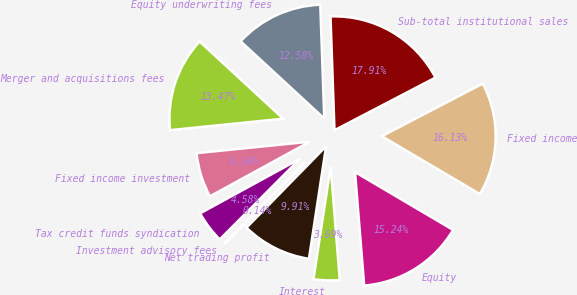<chart> <loc_0><loc_0><loc_500><loc_500><pie_chart><fcel>Equity<fcel>Fixed income<fcel>Sub-total institutional sales<fcel>Equity underwriting fees<fcel>Merger and acquisitions fees<fcel>Fixed income investment<fcel>Tax credit funds syndication<fcel>Investment advisory fees<fcel>Net trading profit<fcel>Interest<nl><fcel>15.24%<fcel>16.13%<fcel>17.91%<fcel>12.58%<fcel>13.47%<fcel>6.36%<fcel>4.58%<fcel>0.14%<fcel>9.91%<fcel>3.69%<nl></chart> 